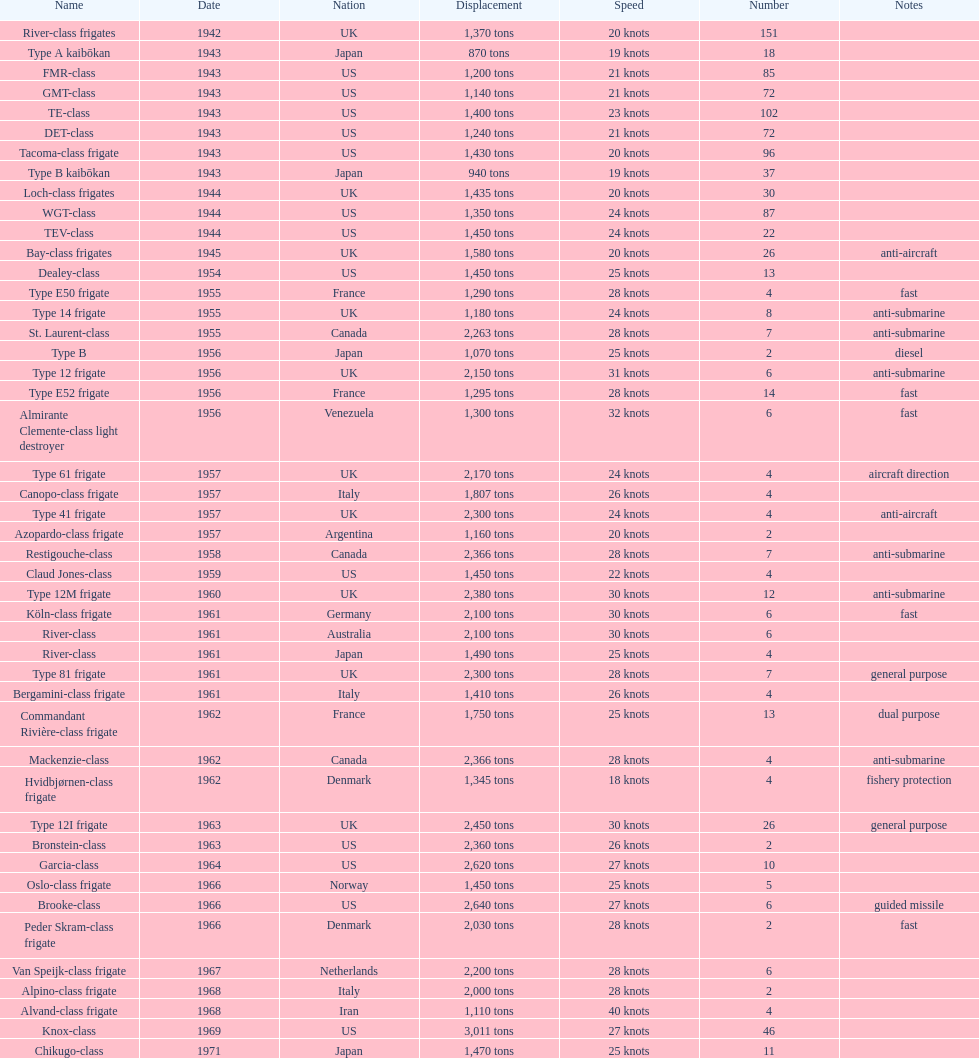How many successive escorts were there in 1943? 7. 